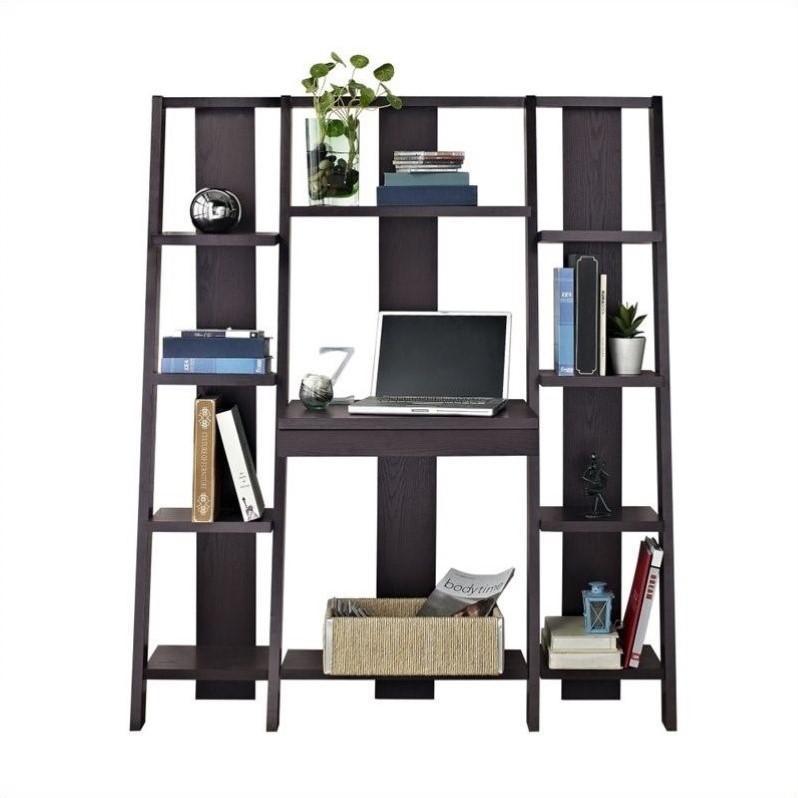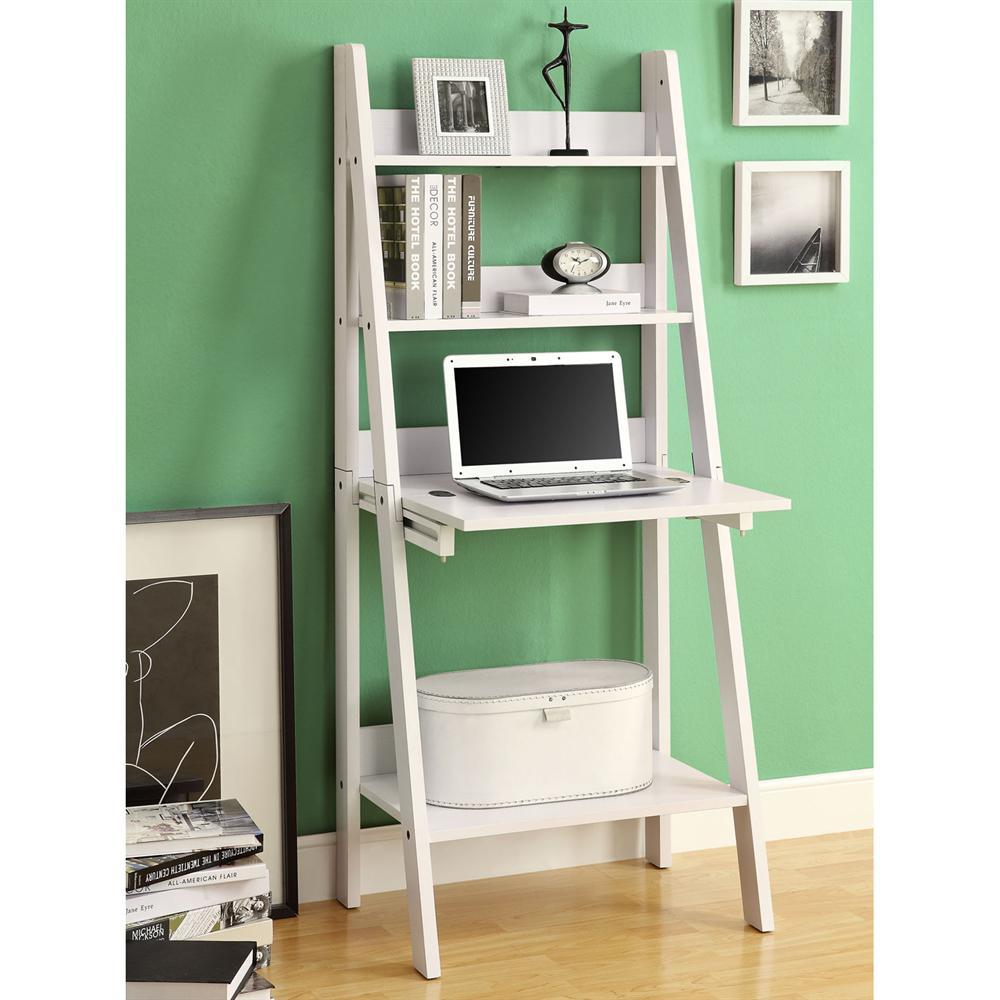The first image is the image on the left, the second image is the image on the right. Evaluate the accuracy of this statement regarding the images: "Both images contain laptops.". Is it true? Answer yes or no. Yes. The first image is the image on the left, the second image is the image on the right. Considering the images on both sides, is "A silver colored laptop is sitting on a black desk that is connected to an entertainment center." valid? Answer yes or no. Yes. 